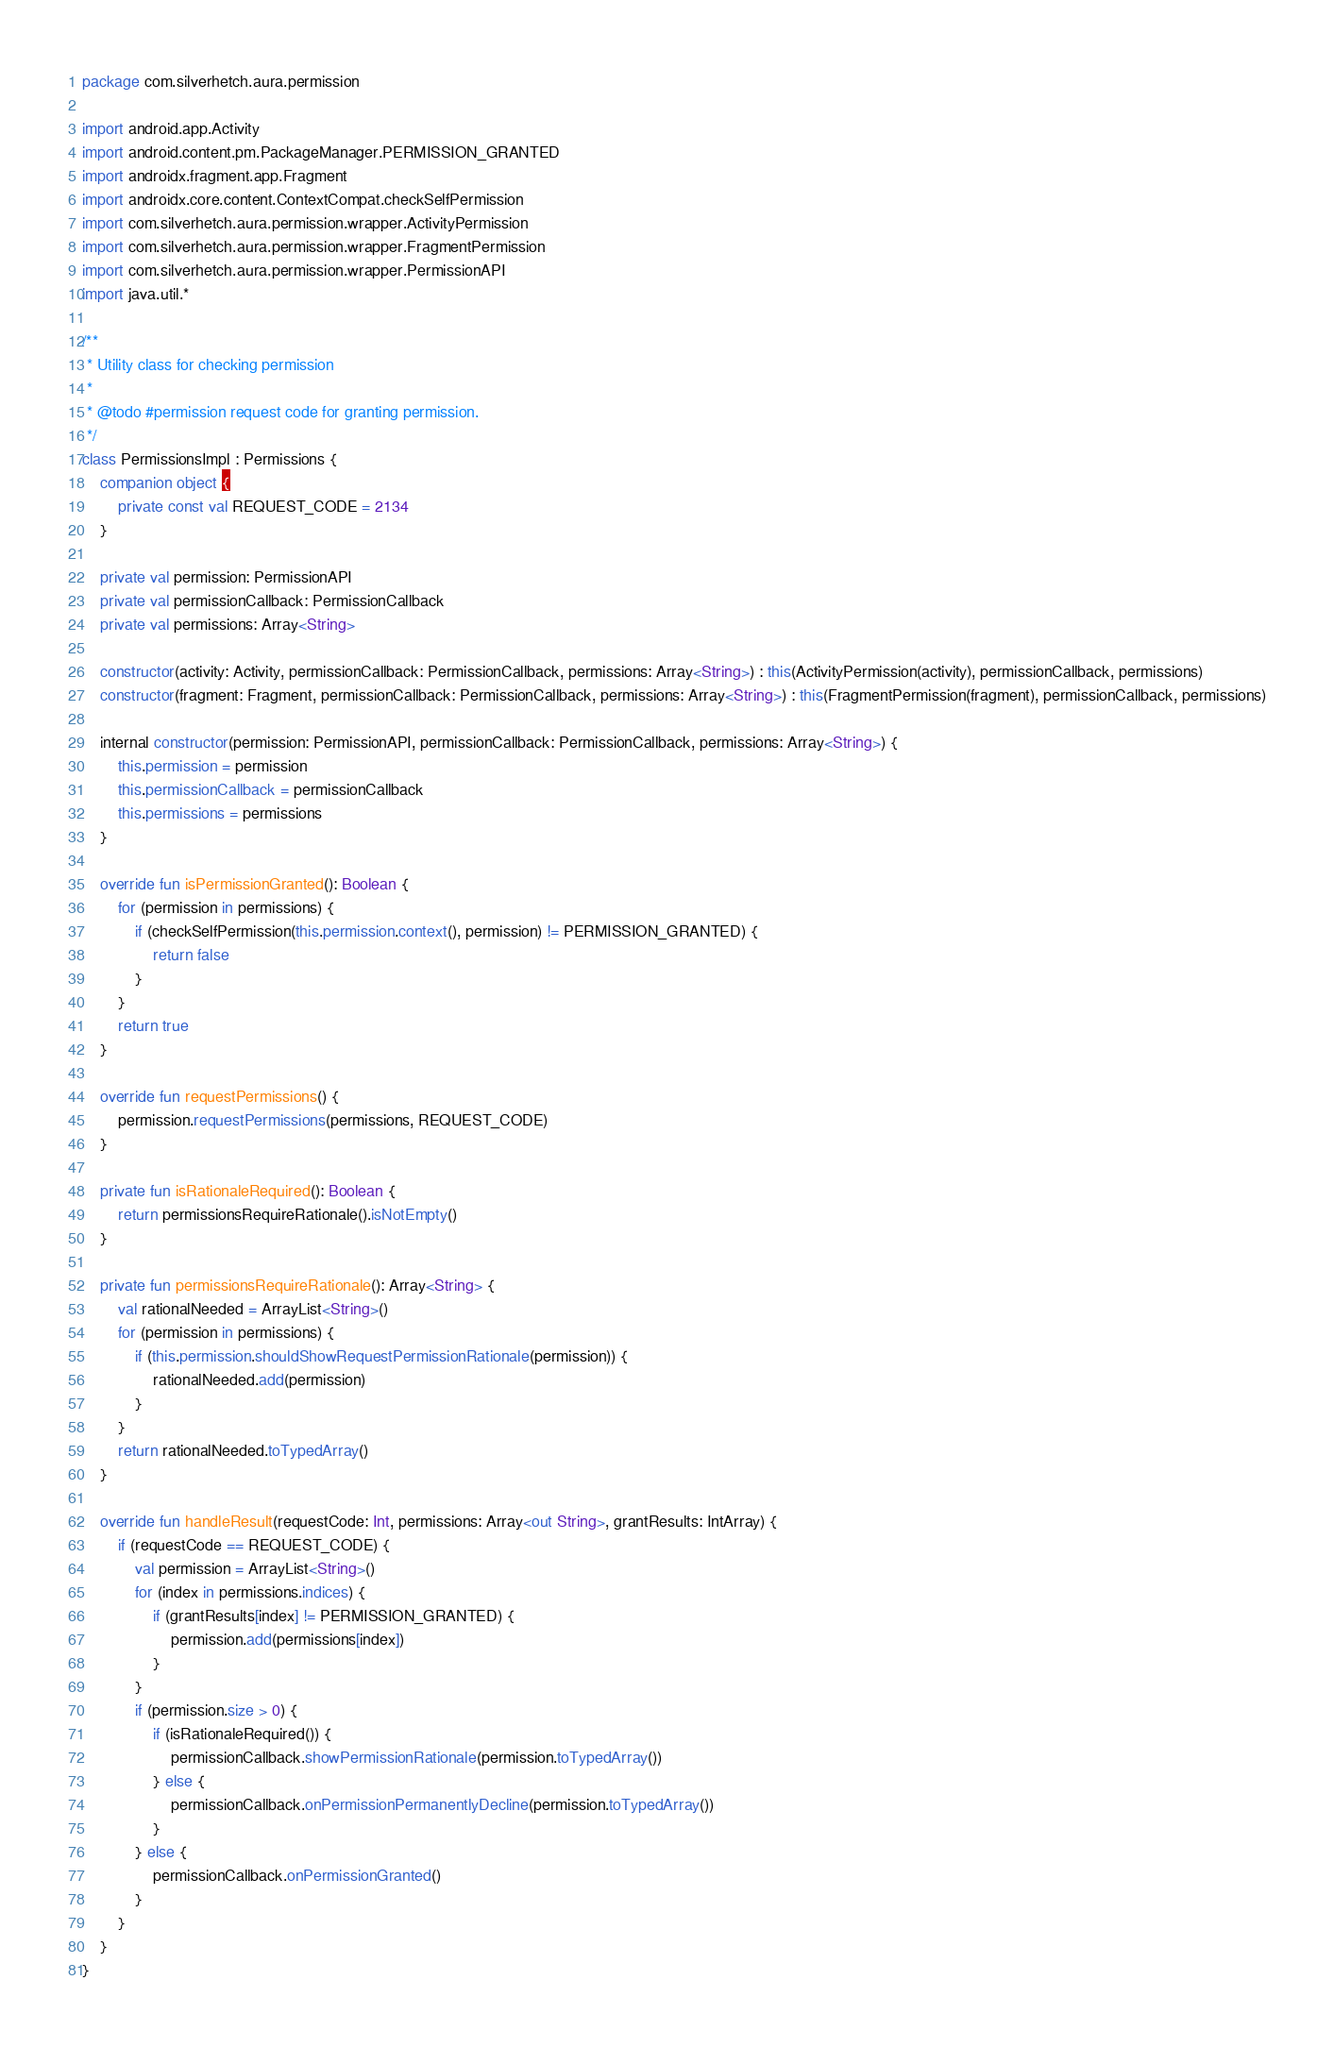<code> <loc_0><loc_0><loc_500><loc_500><_Kotlin_>package com.silverhetch.aura.permission

import android.app.Activity
import android.content.pm.PackageManager.PERMISSION_GRANTED
import androidx.fragment.app.Fragment
import androidx.core.content.ContextCompat.checkSelfPermission
import com.silverhetch.aura.permission.wrapper.ActivityPermission
import com.silverhetch.aura.permission.wrapper.FragmentPermission
import com.silverhetch.aura.permission.wrapper.PermissionAPI
import java.util.*

/**
 * Utility class for checking permission
 *
 * @todo #permission request code for granting permission.
 */
class PermissionsImpl : Permissions {
    companion object {
        private const val REQUEST_CODE = 2134
    }

    private val permission: PermissionAPI
    private val permissionCallback: PermissionCallback
    private val permissions: Array<String>

    constructor(activity: Activity, permissionCallback: PermissionCallback, permissions: Array<String>) : this(ActivityPermission(activity), permissionCallback, permissions)
    constructor(fragment: Fragment, permissionCallback: PermissionCallback, permissions: Array<String>) : this(FragmentPermission(fragment), permissionCallback, permissions)

    internal constructor(permission: PermissionAPI, permissionCallback: PermissionCallback, permissions: Array<String>) {
        this.permission = permission
        this.permissionCallback = permissionCallback
        this.permissions = permissions
    }

    override fun isPermissionGranted(): Boolean {
        for (permission in permissions) {
            if (checkSelfPermission(this.permission.context(), permission) != PERMISSION_GRANTED) {
                return false
            }
        }
        return true
    }

    override fun requestPermissions() {
        permission.requestPermissions(permissions, REQUEST_CODE)
    }

    private fun isRationaleRequired(): Boolean {
        return permissionsRequireRationale().isNotEmpty()
    }

    private fun permissionsRequireRationale(): Array<String> {
        val rationalNeeded = ArrayList<String>()
        for (permission in permissions) {
            if (this.permission.shouldShowRequestPermissionRationale(permission)) {
                rationalNeeded.add(permission)
            }
        }
        return rationalNeeded.toTypedArray()
    }

    override fun handleResult(requestCode: Int, permissions: Array<out String>, grantResults: IntArray) {
        if (requestCode == REQUEST_CODE) {
            val permission = ArrayList<String>()
            for (index in permissions.indices) {
                if (grantResults[index] != PERMISSION_GRANTED) {
                    permission.add(permissions[index])
                }
            }
            if (permission.size > 0) {
                if (isRationaleRequired()) {
                    permissionCallback.showPermissionRationale(permission.toTypedArray())
                } else {
                    permissionCallback.onPermissionPermanentlyDecline(permission.toTypedArray())
                }
            } else {
                permissionCallback.onPermissionGranted()
            }
        }
    }
}
</code> 